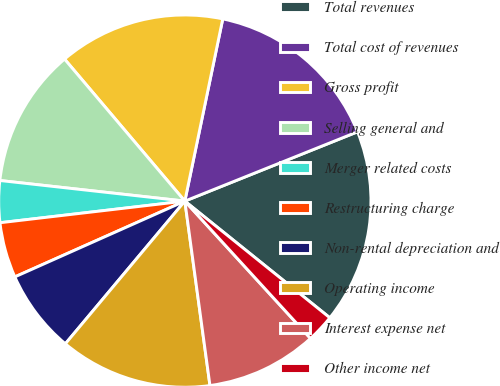<chart> <loc_0><loc_0><loc_500><loc_500><pie_chart><fcel>Total revenues<fcel>Total cost of revenues<fcel>Gross profit<fcel>Selling general and<fcel>Merger related costs<fcel>Restructuring charge<fcel>Non-rental depreciation and<fcel>Operating income<fcel>Interest expense net<fcel>Other income net<nl><fcel>16.86%<fcel>15.66%<fcel>14.45%<fcel>12.05%<fcel>3.62%<fcel>4.82%<fcel>7.23%<fcel>13.25%<fcel>9.64%<fcel>2.42%<nl></chart> 